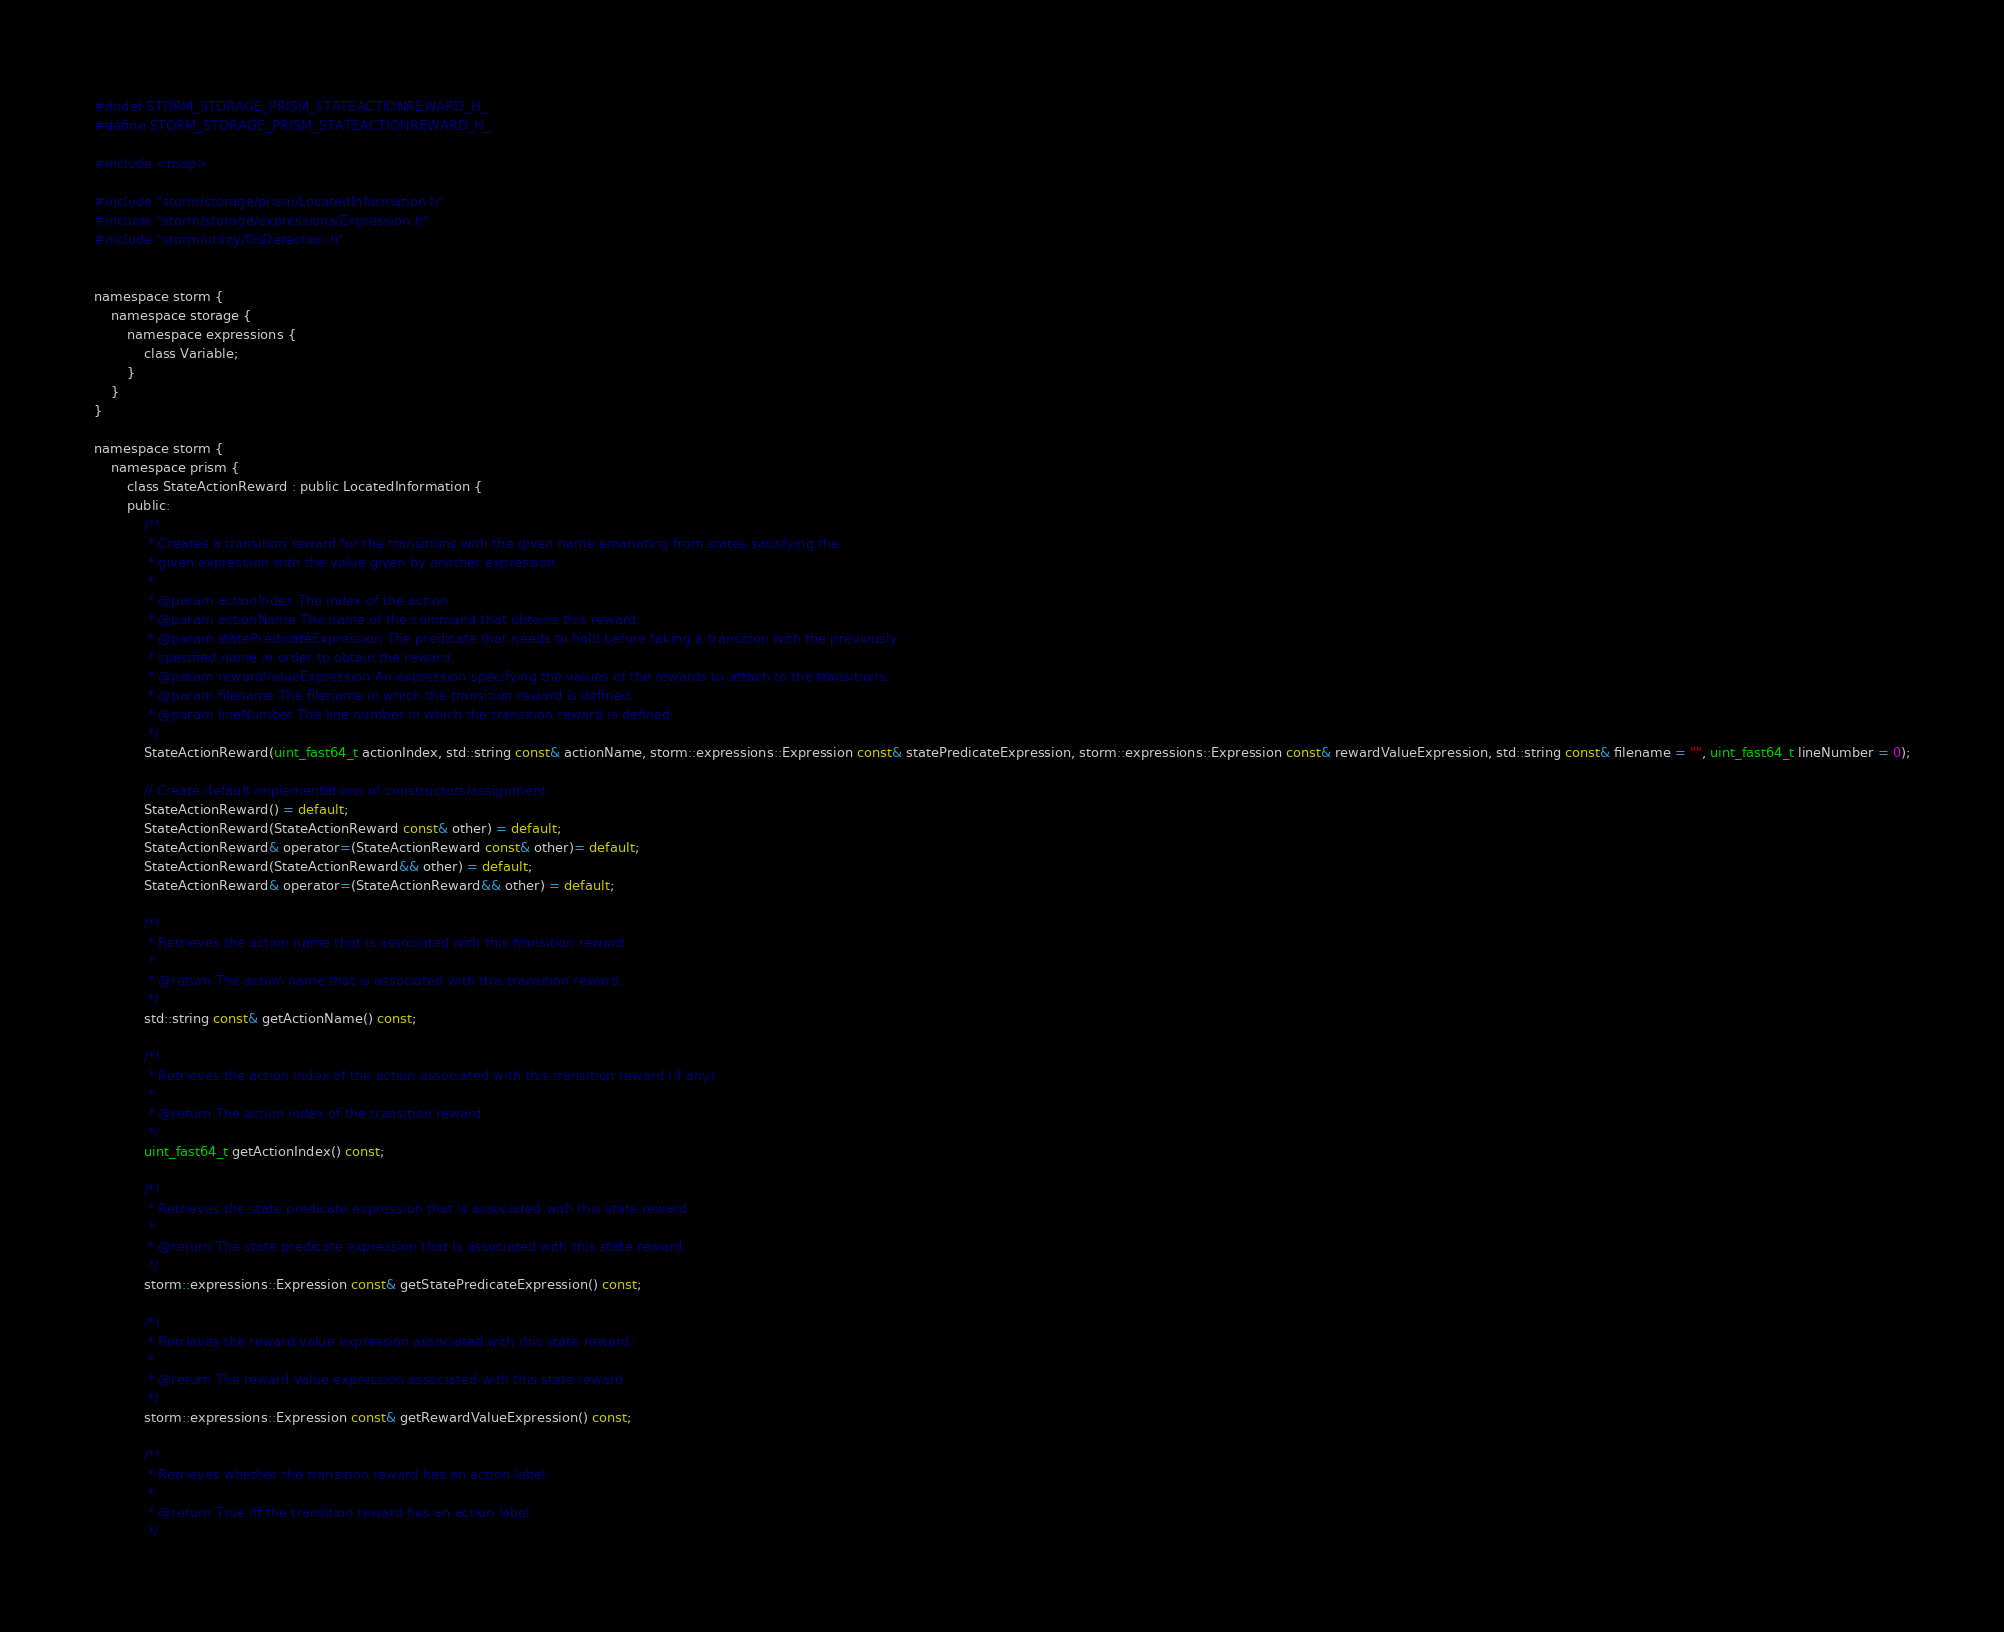Convert code to text. <code><loc_0><loc_0><loc_500><loc_500><_C_>#ifndef STORM_STORAGE_PRISM_STATEACTIONREWARD_H_
#define STORM_STORAGE_PRISM_STATEACTIONREWARD_H_

#include <map>

#include "storm/storage/prism/LocatedInformation.h"
#include "storm/storage/expressions/Expression.h"
#include "storm/utility/OsDetection.h"


namespace storm {
    namespace storage {
        namespace expressions {
            class Variable;
        }
    }
}

namespace storm {
    namespace prism {
        class StateActionReward : public LocatedInformation {
        public:
            /*!
             * Creates a transition reward for the transitions with the given name emanating from states satisfying the
             * given expression with the value given by another expression.
             *
             * @param actionIndex The index of the action.
             * @param actionName The name of the command that obtains this reward.
             * @param statePredicateExpression The predicate that needs to hold before taking a transition with the previously
             * specified name in order to obtain the reward.
             * @param rewardValueExpression An expression specifying the values of the rewards to attach to the transitions.
             * @param filename The filename in which the transition reward is defined.
             * @param lineNumber The line number in which the transition reward is defined.
             */
            StateActionReward(uint_fast64_t actionIndex, std::string const& actionName, storm::expressions::Expression const& statePredicateExpression, storm::expressions::Expression const& rewardValueExpression, std::string const& filename = "", uint_fast64_t lineNumber = 0);
            
            // Create default implementations of constructors/assignment.
            StateActionReward() = default;
            StateActionReward(StateActionReward const& other) = default;
            StateActionReward& operator=(StateActionReward const& other)= default;
            StateActionReward(StateActionReward&& other) = default;
            StateActionReward& operator=(StateActionReward&& other) = default;

            /*!
             * Retrieves the action name that is associated with this transition reward.
             *
             * @return The action name that is associated with this transition reward.
             */
            std::string const& getActionName() const;
            
            /*!
             * Retrieves the action index of the action associated with this transition reward (if any).
             *
             * @return The action index of the transition reward.
             */
            uint_fast64_t getActionIndex() const;
            
            /*!
             * Retrieves the state predicate expression that is associated with this state reward.
             *
             * @return The state predicate expression that is associated with this state reward.
             */
            storm::expressions::Expression const& getStatePredicateExpression() const;
            
            /*!
             * Retrieves the reward value expression associated with this state reward.
             *
             * @return The reward value expression associated with this state reward.
             */
            storm::expressions::Expression const& getRewardValueExpression() const;
            
            /*!
             * Retrieves whether the transition reward has an action label.
             *
             * @return True iff the transition reward has an action label.
             */</code> 